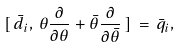<formula> <loc_0><loc_0><loc_500><loc_500>[ \, \bar { d } _ { i } , \, \theta \frac { \partial } { \partial \theta } + \bar { \theta } \frac { \partial } { \partial \bar { \theta } } \, ] \, = \, \bar { q } _ { i } ,</formula> 